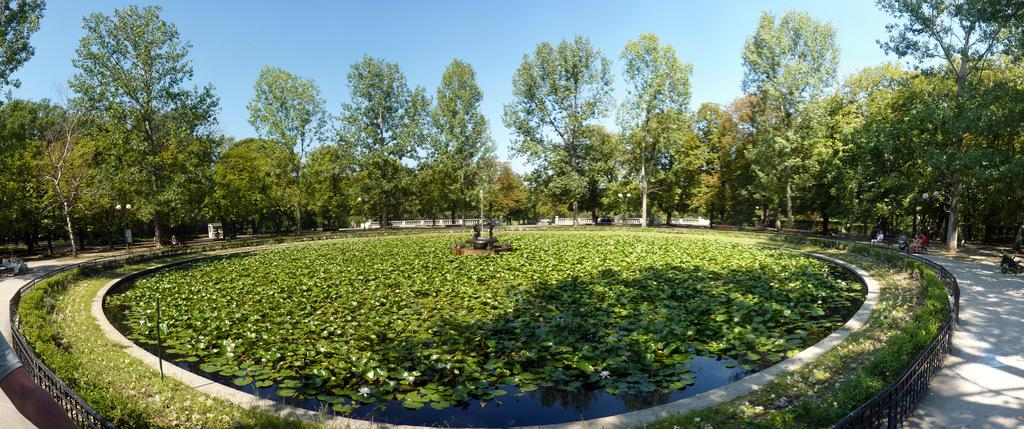How many people are in the image? There are people in the image, but the exact number is not specified. What type of ground is visible in the image? The ground has grass in the image. What is the purpose of the fencing in the image? The purpose of the fencing in the image is not specified. What is the water in the image used for? The water in the image contains leaves and flowers, which suggests it might be part of a decorative feature. What is the fountain in the image used for? The fountain in the image is likely used for decoration or as a water feature. What type of vegetation is visible in the image? There are trees in the image. What is visible in the sky in the image? The sky is visible in the image, but no specific details are provided. How does the zebra feel about the flowers in the water? There is no zebra present in the image, so it is not possible to determine how it might feel about the flowers in the water. 